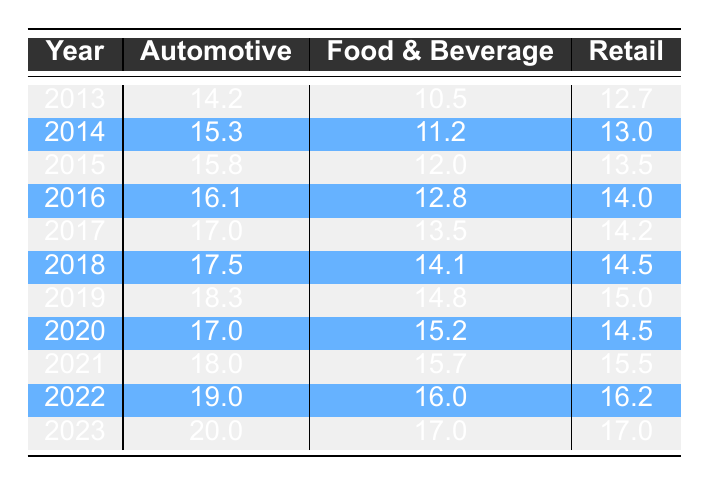What was the advertising spend in the automotive industry in 2020? According to the table, the spend in the automotive industry for the year 2020 is specifically listed under that year, which shows a value of 17.0 billion.
Answer: 17.0 billion Which industry had the highest advertising spend in 2023? Looking at the table for the year 2023, the spend for each industry is listed, with Automotive at 20.0 billion, Food & Beverage at 17.0 billion, and Retail at 17.0 billion. The highest value is 20.0 billion for the Automotive industry.
Answer: Automotive What is the total advertising spend across all industries in 2018? In 2018, the automotive spend is 17.5 billion, Food & Beverage is 14.1 billion, and Retail is 14.5 billion. Adding these amounts together gives 17.5 + 14.1 + 14.5 = 46.1 billion.
Answer: 46.1 billion Is the advertising spend in the Food & Beverage industry higher in 2021 or in 2022? The table shows the spend in Food & Beverage for 2021 as 15.7 billion and for 2022 as 16.0 billion. Comparing these values indicates that 16.0 billion is greater than 15.7 billion, so 2022 has a higher spend.
Answer: Yes What was the percentage increase in advertising spend for Retail from 2013 to 2023? Retail spend in 2013 was 12.7 billion and in 2023 it was 17.0 billion. The increase is 17.0 - 12.7 = 4.3 billion. To find the percentage increase: (4.3 / 12.7) * 100 = approximately 33.86%.
Answer: 33.86% Which industry had the smallest increase in advertising spend from 2017 to 2018? From the table, the spend for Automotive increased from 17.0 to 17.5, which is an increase of 0.5 billion. For Food & Beverage, it increased from 13.5 to 14.1, an increase of 0.6 billion. For Retail, it went from 14.2 to 14.5, an increase of 0.3 billion. Comparing these, Retail has the smallest increase of 0.3 billion.
Answer: Retail Was there a decrease in advertising spend in any industry from 2019 to 2020? The Automotive spend dropped from 18.3 billion in 2019 to 17.0 billion in 2020, which indicates a decrease. Food & Beverage went from 14.8 billion to 15.2 billion (an increase), and Retail decreased from 15.0 billion to 14.5 billion. Thus, Automotive and Retail experienced decreases.
Answer: Yes What was the overall trend in advertising spending from 2013 to 2023 for the Automotive industry? By reviewing the table, the spend in the Automotive industry shows a clear upward trend, increasing from 14.2 billion in 2013 to 20.0 billion in 2023. Each year reflects a steady increase, confirming the overall trend of growth.
Answer: Increasing 